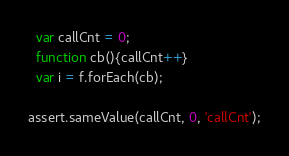Convert code to text. <code><loc_0><loc_0><loc_500><loc_500><_JavaScript_>
  var callCnt = 0;
  function cb(){callCnt++}
  var i = f.forEach(cb);  

assert.sameValue(callCnt, 0, 'callCnt');
</code> 